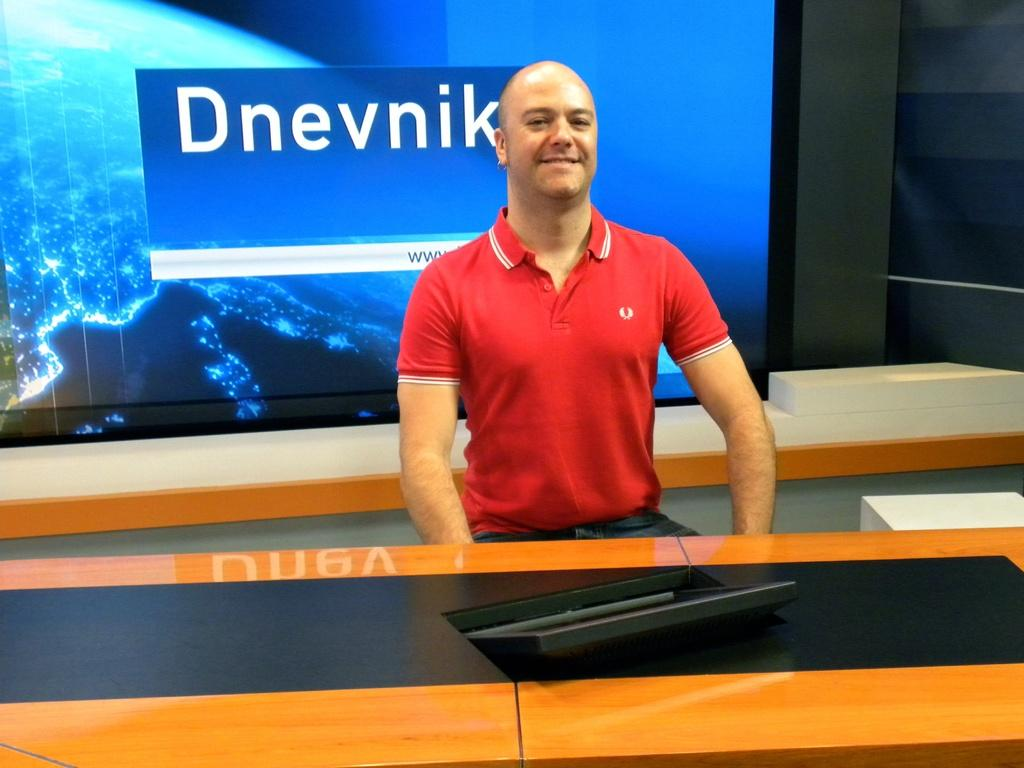Provide a one-sentence caption for the provided image. A man in a red polo with a screen behind him reading Dnevnik. 